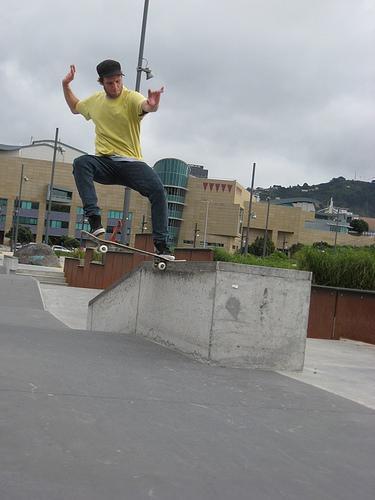What kind of trick is this skateboarder performing?
Choose the correct response and explain in the format: 'Answer: answer
Rationale: rationale.'
Options: Tail slide, rail slide, truck grind, nose grind. Answer: tail slide.
Rationale: The skateboarder is performing a slide with the tail of the skateboard. 